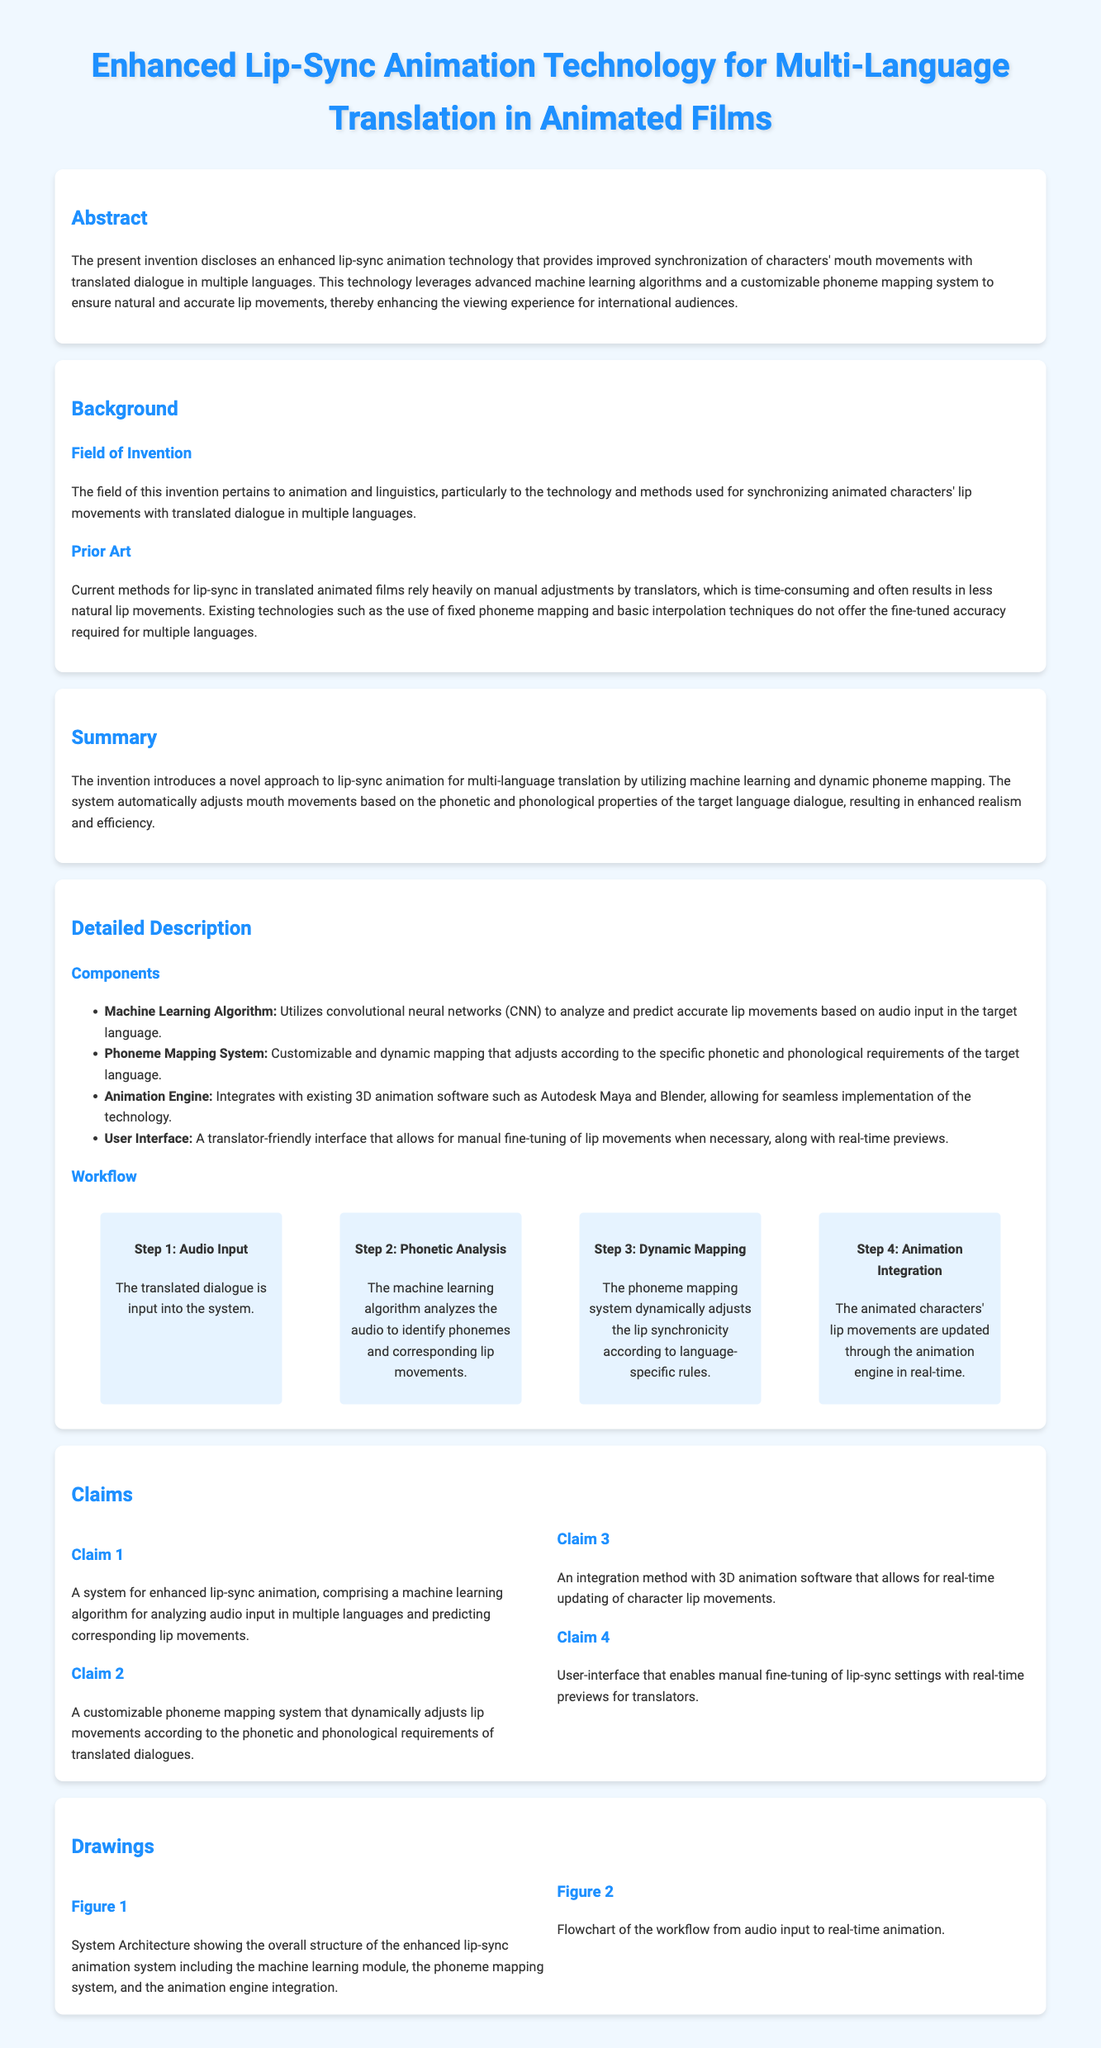What is the title of the invention? The title of the invention is clearly stated at the top of the document, which outlines the focus of the patent.
Answer: Enhanced Lip-Sync Animation Technology for Multi-Language Translation in Animated Films What technology does the invention utilize? The technology mentioned in the document includes machine learning and dynamic phoneme mapping, which are essential components of the invention.
Answer: Machine learning and dynamic phoneme mapping What is the primary advantage of the invention? The primary advantage is improving synchronization of characters' mouth movements with translated dialogue for international audiences, enhancing their viewing experience.
Answer: Improved synchronization How many claims are listed in the document? The claims section contains a specific number of claims that outline the features of the invention.
Answer: Four claims What is the first step in the workflow? The workflow section identifies distinct steps, with the first step explicitly mentioned at the beginning.
Answer: Audio Input Which software does the technology integrate with? The document specifies integration with 3D animation software, particularly mentioning well-known animation tools used in the industry.
Answer: Autodesk Maya and Blender What does the user interface allow translators to do? The user interface is described in the document, highlighting its functionality for users in the translation process.
Answer: Manual fine-tuning of lip movements What type of analysis does the machine learning algorithm perform? The description of the components indicates the kind of analysis carried out by the machine learning algorithm in relation to the dialogue input.
Answer: Phonetic analysis Which figure illustrates the workflow? The figures mentioned in the document refer to particular systems or workflows, with one being a flowchart that maps this process.
Answer: Figure 2 